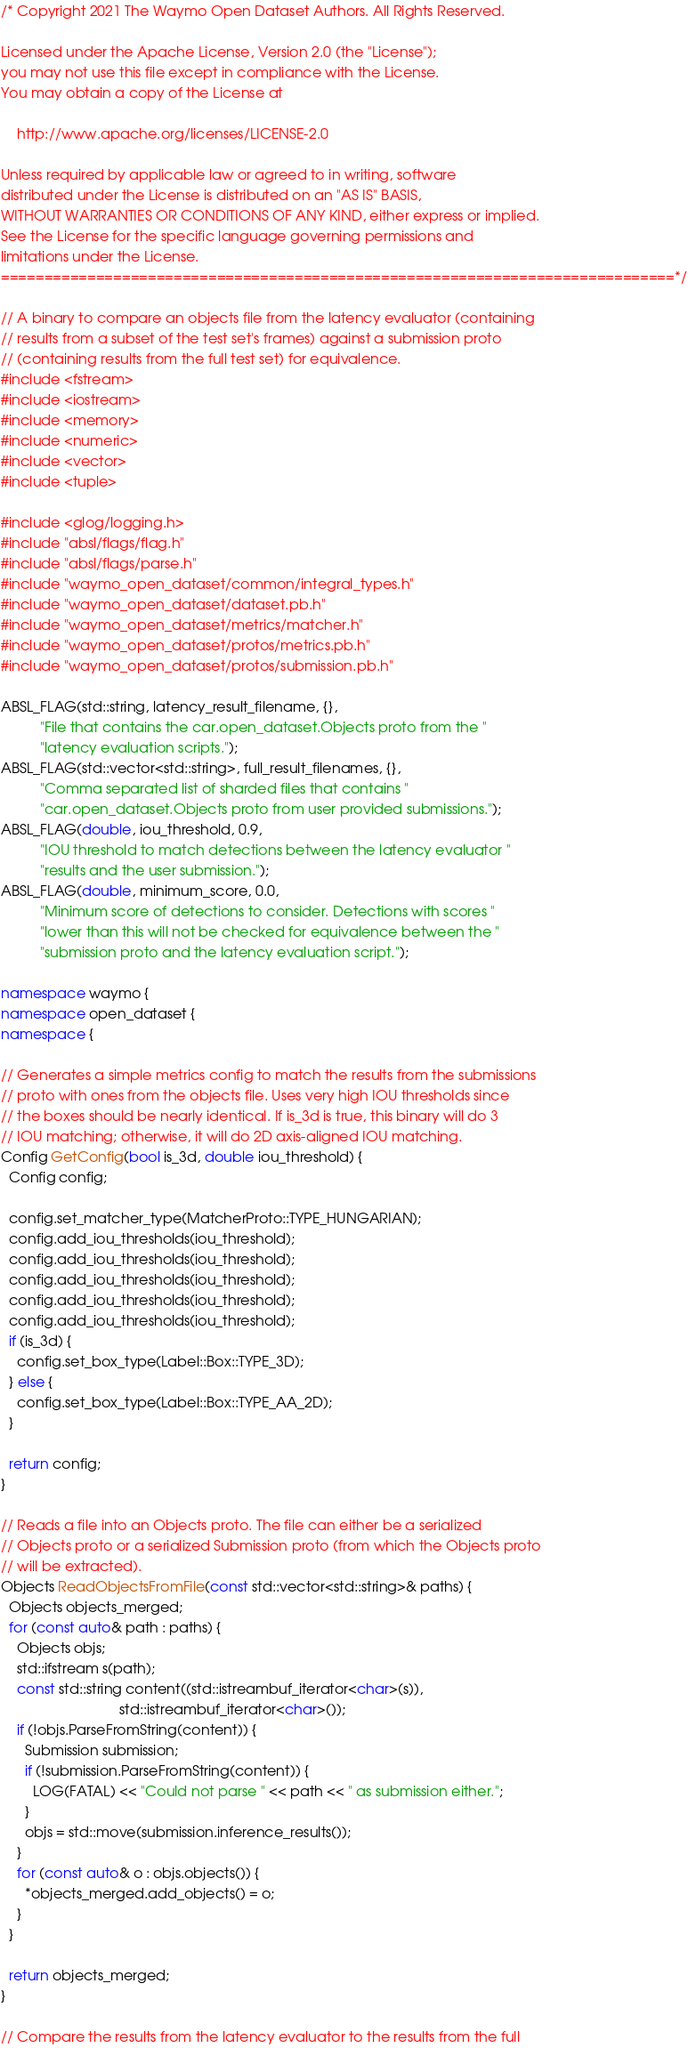<code> <loc_0><loc_0><loc_500><loc_500><_C++_>/* Copyright 2021 The Waymo Open Dataset Authors. All Rights Reserved.

Licensed under the Apache License, Version 2.0 (the "License");
you may not use this file except in compliance with the License.
You may obtain a copy of the License at

    http://www.apache.org/licenses/LICENSE-2.0

Unless required by applicable law or agreed to in writing, software
distributed under the License is distributed on an "AS IS" BASIS,
WITHOUT WARRANTIES OR CONDITIONS OF ANY KIND, either express or implied.
See the License for the specific language governing permissions and
limitations under the License.
==============================================================================*/

// A binary to compare an objects file from the latency evaluator (containing
// results from a subset of the test set's frames) against a submission proto
// (containing results from the full test set) for equivalence.
#include <fstream>
#include <iostream>
#include <memory>
#include <numeric>
#include <vector>
#include <tuple>

#include <glog/logging.h>
#include "absl/flags/flag.h"
#include "absl/flags/parse.h"
#include "waymo_open_dataset/common/integral_types.h"
#include "waymo_open_dataset/dataset.pb.h"
#include "waymo_open_dataset/metrics/matcher.h"
#include "waymo_open_dataset/protos/metrics.pb.h"
#include "waymo_open_dataset/protos/submission.pb.h"

ABSL_FLAG(std::string, latency_result_filename, {},
          "File that contains the car.open_dataset.Objects proto from the "
          "latency evaluation scripts.");
ABSL_FLAG(std::vector<std::string>, full_result_filenames, {},
          "Comma separated list of sharded files that contains "
          "car.open_dataset.Objects proto from user provided submissions.");
ABSL_FLAG(double, iou_threshold, 0.9,
          "IOU threshold to match detections between the latency evaluator "
          "results and the user submission.");
ABSL_FLAG(double, minimum_score, 0.0,
          "Minimum score of detections to consider. Detections with scores "
          "lower than this will not be checked for equivalence between the "
          "submission proto and the latency evaluation script.");

namespace waymo {
namespace open_dataset {
namespace {

// Generates a simple metrics config to match the results from the submissions
// proto with ones from the objects file. Uses very high IOU thresholds since
// the boxes should be nearly identical. If is_3d is true, this binary will do 3
// IOU matching; otherwise, it will do 2D axis-aligned IOU matching.
Config GetConfig(bool is_3d, double iou_threshold) {
  Config config;

  config.set_matcher_type(MatcherProto::TYPE_HUNGARIAN);
  config.add_iou_thresholds(iou_threshold);
  config.add_iou_thresholds(iou_threshold);
  config.add_iou_thresholds(iou_threshold);
  config.add_iou_thresholds(iou_threshold);
  config.add_iou_thresholds(iou_threshold);
  if (is_3d) {
    config.set_box_type(Label::Box::TYPE_3D);
  } else {
    config.set_box_type(Label::Box::TYPE_AA_2D);
  }

  return config;
}

// Reads a file into an Objects proto. The file can either be a serialized
// Objects proto or a serialized Submission proto (from which the Objects proto
// will be extracted).
Objects ReadObjectsFromFile(const std::vector<std::string>& paths) {
  Objects objects_merged;
  for (const auto& path : paths) {
    Objects objs;
    std::ifstream s(path);
    const std::string content((std::istreambuf_iterator<char>(s)),
                              std::istreambuf_iterator<char>());
    if (!objs.ParseFromString(content)) {
      Submission submission;
      if (!submission.ParseFromString(content)) {
        LOG(FATAL) << "Could not parse " << path << " as submission either.";
      }
      objs = std::move(submission.inference_results());
    }
    for (const auto& o : objs.objects()) {
      *objects_merged.add_objects() = o;
    }
  }

  return objects_merged;
}

// Compare the results from the latency evaluator to the results from the full</code> 